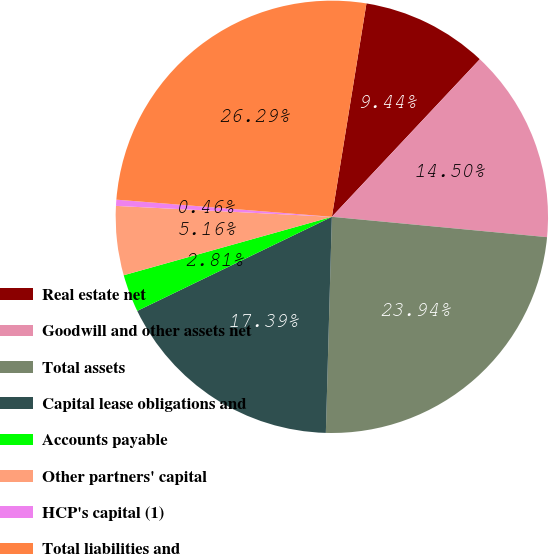<chart> <loc_0><loc_0><loc_500><loc_500><pie_chart><fcel>Real estate net<fcel>Goodwill and other assets net<fcel>Total assets<fcel>Capital lease obligations and<fcel>Accounts payable<fcel>Other partners' capital<fcel>HCP's capital (1)<fcel>Total liabilities and<nl><fcel>9.44%<fcel>14.5%<fcel>23.94%<fcel>17.39%<fcel>2.81%<fcel>5.16%<fcel>0.46%<fcel>26.29%<nl></chart> 